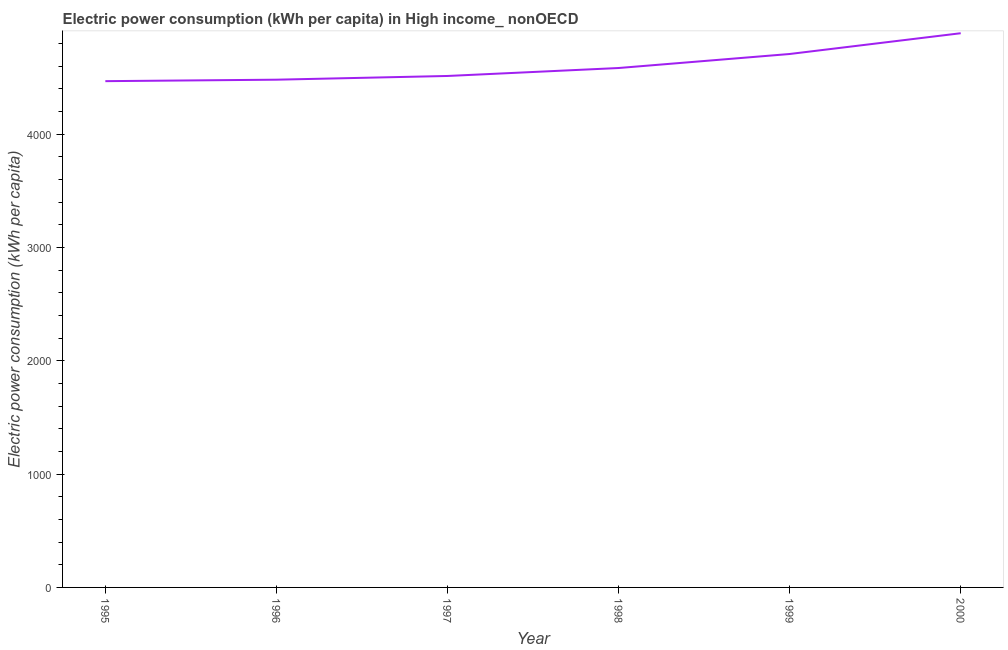What is the electric power consumption in 1995?
Offer a terse response. 4467.42. Across all years, what is the maximum electric power consumption?
Your response must be concise. 4890.47. Across all years, what is the minimum electric power consumption?
Keep it short and to the point. 4467.42. What is the sum of the electric power consumption?
Offer a terse response. 2.76e+04. What is the difference between the electric power consumption in 1995 and 2000?
Ensure brevity in your answer.  -423.05. What is the average electric power consumption per year?
Offer a very short reply. 4607.02. What is the median electric power consumption?
Your answer should be very brief. 4548.31. In how many years, is the electric power consumption greater than 4200 kWh per capita?
Ensure brevity in your answer.  6. What is the ratio of the electric power consumption in 1995 to that in 1997?
Your answer should be very brief. 0.99. Is the electric power consumption in 1995 less than that in 1997?
Offer a very short reply. Yes. Is the difference between the electric power consumption in 1997 and 1999 greater than the difference between any two years?
Offer a terse response. No. What is the difference between the highest and the second highest electric power consumption?
Your answer should be very brief. 183.34. What is the difference between the highest and the lowest electric power consumption?
Make the answer very short. 423.05. Does the electric power consumption monotonically increase over the years?
Give a very brief answer. Yes. How many years are there in the graph?
Your response must be concise. 6. What is the difference between two consecutive major ticks on the Y-axis?
Provide a succinct answer. 1000. Does the graph contain any zero values?
Provide a short and direct response. No. What is the title of the graph?
Offer a terse response. Electric power consumption (kWh per capita) in High income_ nonOECD. What is the label or title of the Y-axis?
Ensure brevity in your answer.  Electric power consumption (kWh per capita). What is the Electric power consumption (kWh per capita) of 1995?
Provide a short and direct response. 4467.42. What is the Electric power consumption (kWh per capita) in 1996?
Offer a terse response. 4480.49. What is the Electric power consumption (kWh per capita) in 1997?
Provide a succinct answer. 4513.2. What is the Electric power consumption (kWh per capita) in 1998?
Provide a short and direct response. 4583.42. What is the Electric power consumption (kWh per capita) of 1999?
Offer a terse response. 4707.13. What is the Electric power consumption (kWh per capita) in 2000?
Your answer should be very brief. 4890.47. What is the difference between the Electric power consumption (kWh per capita) in 1995 and 1996?
Keep it short and to the point. -13.07. What is the difference between the Electric power consumption (kWh per capita) in 1995 and 1997?
Make the answer very short. -45.78. What is the difference between the Electric power consumption (kWh per capita) in 1995 and 1998?
Your response must be concise. -116. What is the difference between the Electric power consumption (kWh per capita) in 1995 and 1999?
Keep it short and to the point. -239.71. What is the difference between the Electric power consumption (kWh per capita) in 1995 and 2000?
Offer a terse response. -423.05. What is the difference between the Electric power consumption (kWh per capita) in 1996 and 1997?
Provide a short and direct response. -32.71. What is the difference between the Electric power consumption (kWh per capita) in 1996 and 1998?
Keep it short and to the point. -102.93. What is the difference between the Electric power consumption (kWh per capita) in 1996 and 1999?
Offer a terse response. -226.64. What is the difference between the Electric power consumption (kWh per capita) in 1996 and 2000?
Make the answer very short. -409.98. What is the difference between the Electric power consumption (kWh per capita) in 1997 and 1998?
Keep it short and to the point. -70.22. What is the difference between the Electric power consumption (kWh per capita) in 1997 and 1999?
Keep it short and to the point. -193.93. What is the difference between the Electric power consumption (kWh per capita) in 1997 and 2000?
Your answer should be very brief. -377.27. What is the difference between the Electric power consumption (kWh per capita) in 1998 and 1999?
Make the answer very short. -123.7. What is the difference between the Electric power consumption (kWh per capita) in 1998 and 2000?
Your response must be concise. -307.04. What is the difference between the Electric power consumption (kWh per capita) in 1999 and 2000?
Provide a short and direct response. -183.34. What is the ratio of the Electric power consumption (kWh per capita) in 1995 to that in 1996?
Ensure brevity in your answer.  1. What is the ratio of the Electric power consumption (kWh per capita) in 1995 to that in 1999?
Ensure brevity in your answer.  0.95. What is the ratio of the Electric power consumption (kWh per capita) in 1995 to that in 2000?
Make the answer very short. 0.91. What is the ratio of the Electric power consumption (kWh per capita) in 1996 to that in 2000?
Keep it short and to the point. 0.92. What is the ratio of the Electric power consumption (kWh per capita) in 1997 to that in 1998?
Offer a terse response. 0.98. What is the ratio of the Electric power consumption (kWh per capita) in 1997 to that in 2000?
Make the answer very short. 0.92. What is the ratio of the Electric power consumption (kWh per capita) in 1998 to that in 1999?
Ensure brevity in your answer.  0.97. What is the ratio of the Electric power consumption (kWh per capita) in 1998 to that in 2000?
Provide a short and direct response. 0.94. 